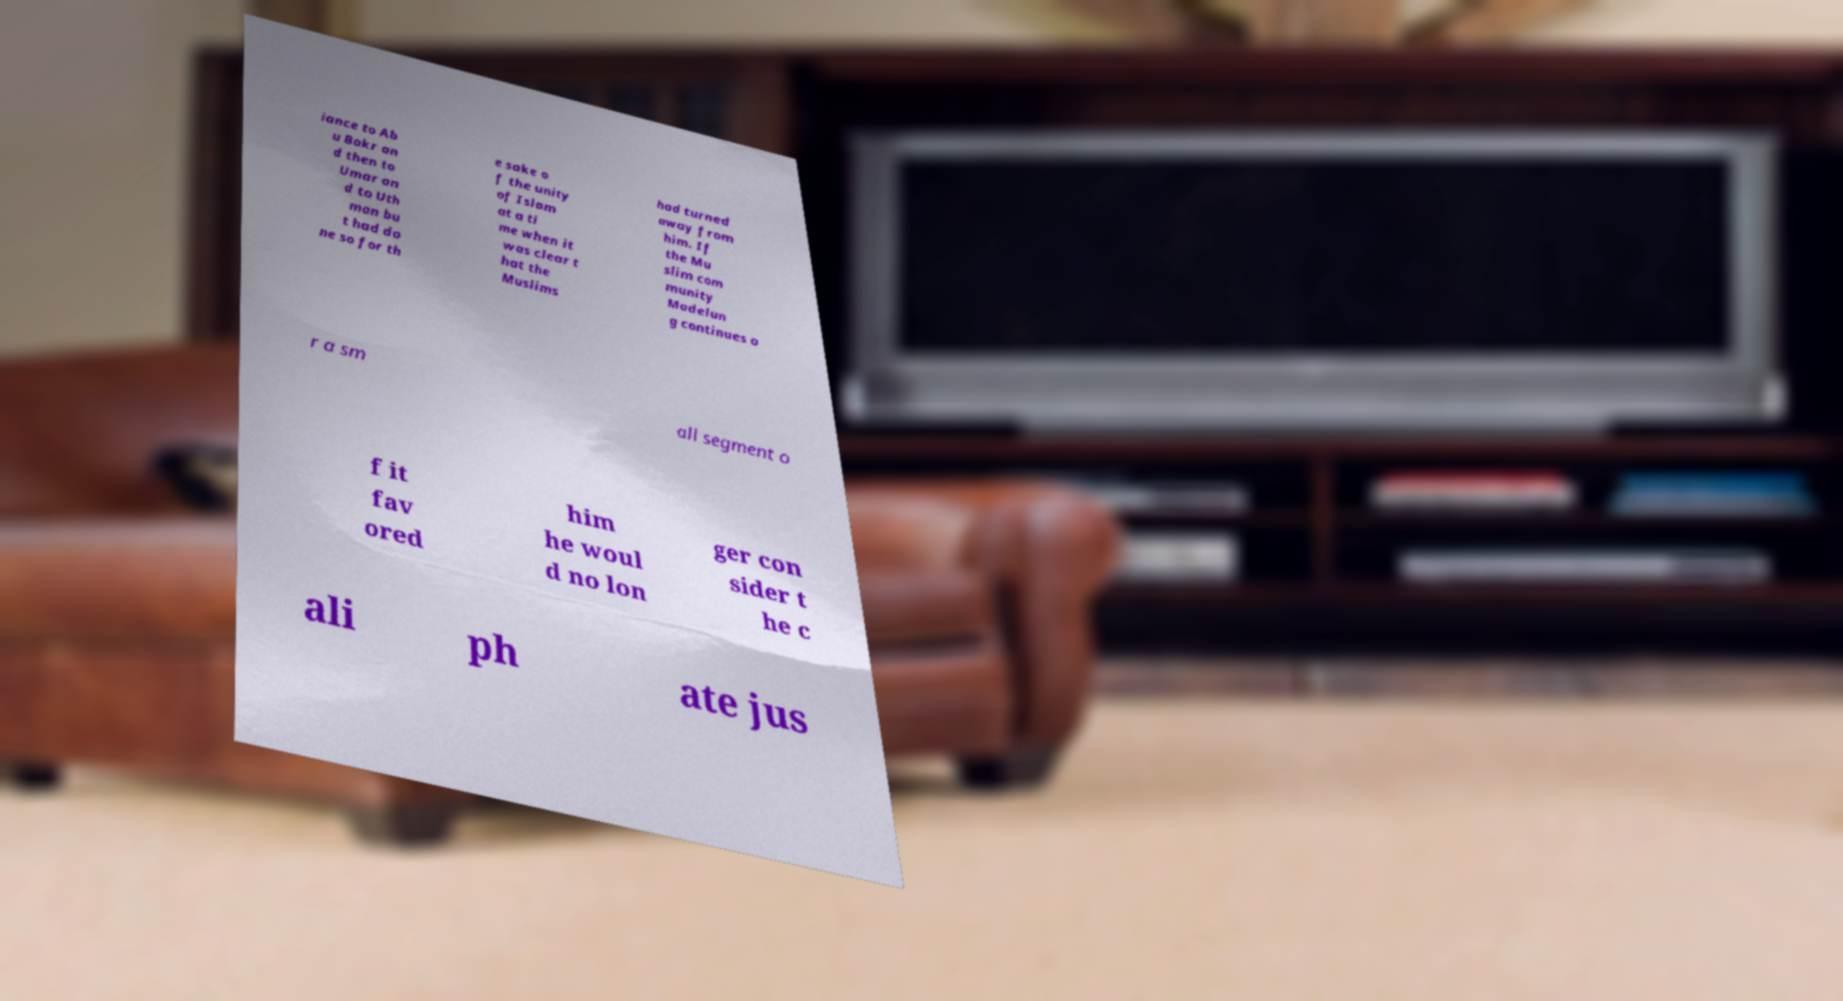What messages or text are displayed in this image? I need them in a readable, typed format. iance to Ab u Bakr an d then to Umar an d to Uth man bu t had do ne so for th e sake o f the unity of Islam at a ti me when it was clear t hat the Muslims had turned away from him. If the Mu slim com munity Madelun g continues o r a sm all segment o f it fav ored him he woul d no lon ger con sider t he c ali ph ate jus 